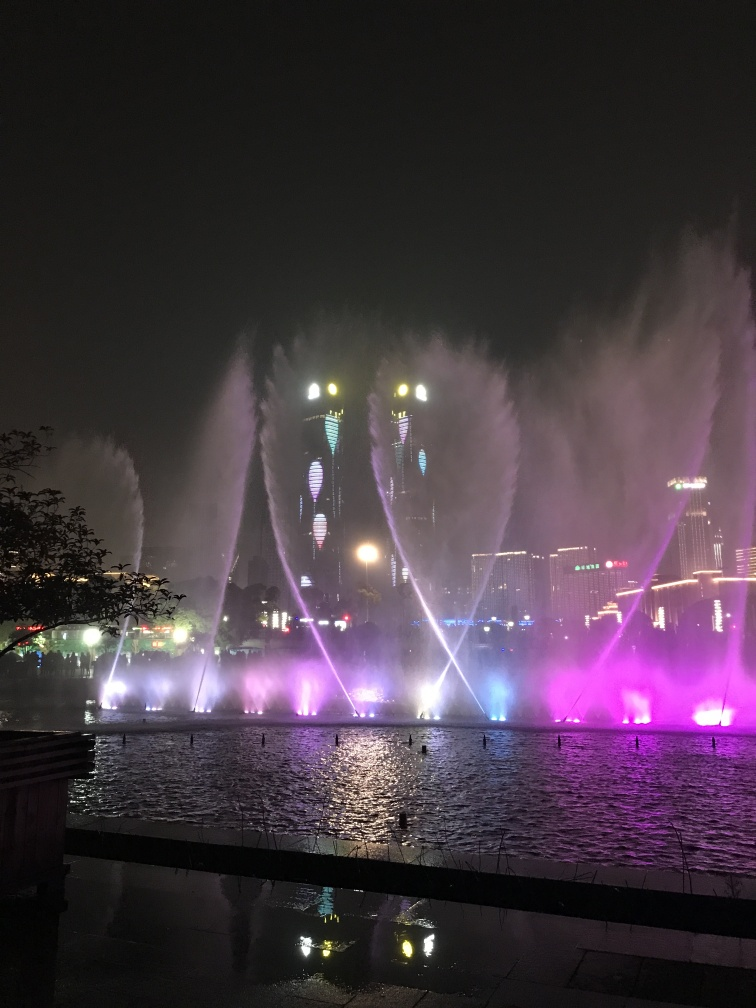Is the composition of the image decent? The composition of the image is striking, with a well-balanced mix of elements. It features a captivating display of water fountains illuminated by purple and blue lights, creating a dramatic and colorful spectacle against the night sky. The inclusion of reflected city lights and the silhouette of the foreground provides depth, enhancing the photograph's visual appeal. 